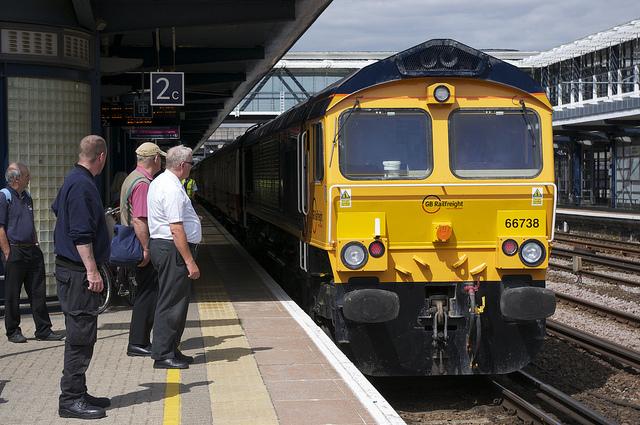What are the people waiting to do?
Quick response, please. Board train. How many people are waiting to get on the train?
Give a very brief answer. 4. Is there woman in this photo?
Answer briefly. No. What is the number on the train?
Concise answer only. 66738. What color is the man's shirt?
Give a very brief answer. White. 